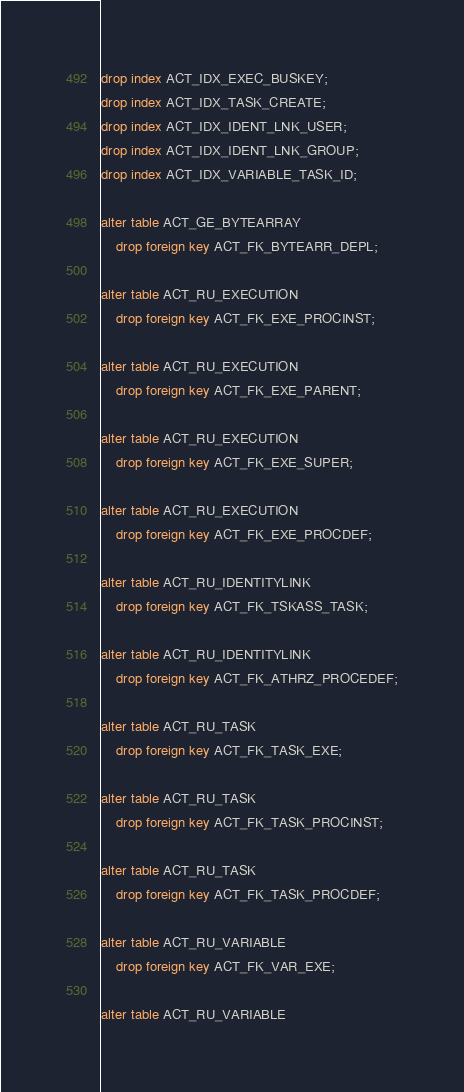<code> <loc_0><loc_0><loc_500><loc_500><_SQL_>drop index ACT_IDX_EXEC_BUSKEY;
drop index ACT_IDX_TASK_CREATE;
drop index ACT_IDX_IDENT_LNK_USER;
drop index ACT_IDX_IDENT_LNK_GROUP;
drop index ACT_IDX_VARIABLE_TASK_ID;

alter table ACT_GE_BYTEARRAY
    drop foreign key ACT_FK_BYTEARR_DEPL;

alter table ACT_RU_EXECUTION
    drop foreign key ACT_FK_EXE_PROCINST;

alter table ACT_RU_EXECUTION
    drop foreign key ACT_FK_EXE_PARENT;

alter table ACT_RU_EXECUTION
    drop foreign key ACT_FK_EXE_SUPER;

alter table ACT_RU_EXECUTION
    drop foreign key ACT_FK_EXE_PROCDEF;

alter table ACT_RU_IDENTITYLINK
    drop foreign key ACT_FK_TSKASS_TASK;

alter table ACT_RU_IDENTITYLINK
    drop foreign key ACT_FK_ATHRZ_PROCEDEF;

alter table ACT_RU_TASK
	drop foreign key ACT_FK_TASK_EXE;

alter table ACT_RU_TASK
	drop foreign key ACT_FK_TASK_PROCINST;

alter table ACT_RU_TASK
	drop foreign key ACT_FK_TASK_PROCDEF;

alter table ACT_RU_VARIABLE
    drop foreign key ACT_FK_VAR_EXE;

alter table ACT_RU_VARIABLE</code> 